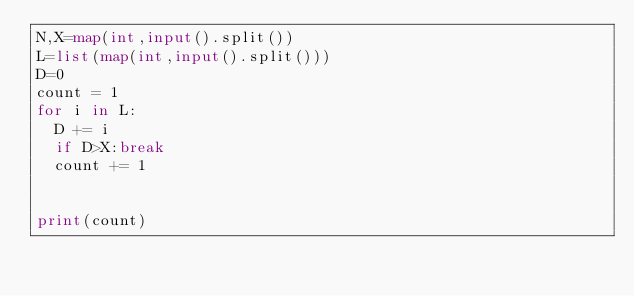Convert code to text. <code><loc_0><loc_0><loc_500><loc_500><_Python_>N,X=map(int,input().split())
L=list(map(int,input().split()))
D=0
count = 1
for i in L:
  D += i
  if D>X:break
  count += 1
  
  
print(count)  </code> 